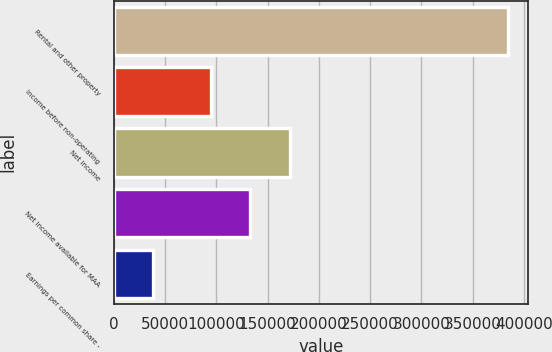Convert chart to OTSL. <chart><loc_0><loc_0><loc_500><loc_500><bar_chart><fcel>Rental and other property<fcel>Income before non-operating<fcel>Net income<fcel>Net income available for MAA<fcel>Earnings per common share -<nl><fcel>384550<fcel>94671<fcel>171581<fcel>133126<fcel>38455.9<nl></chart> 